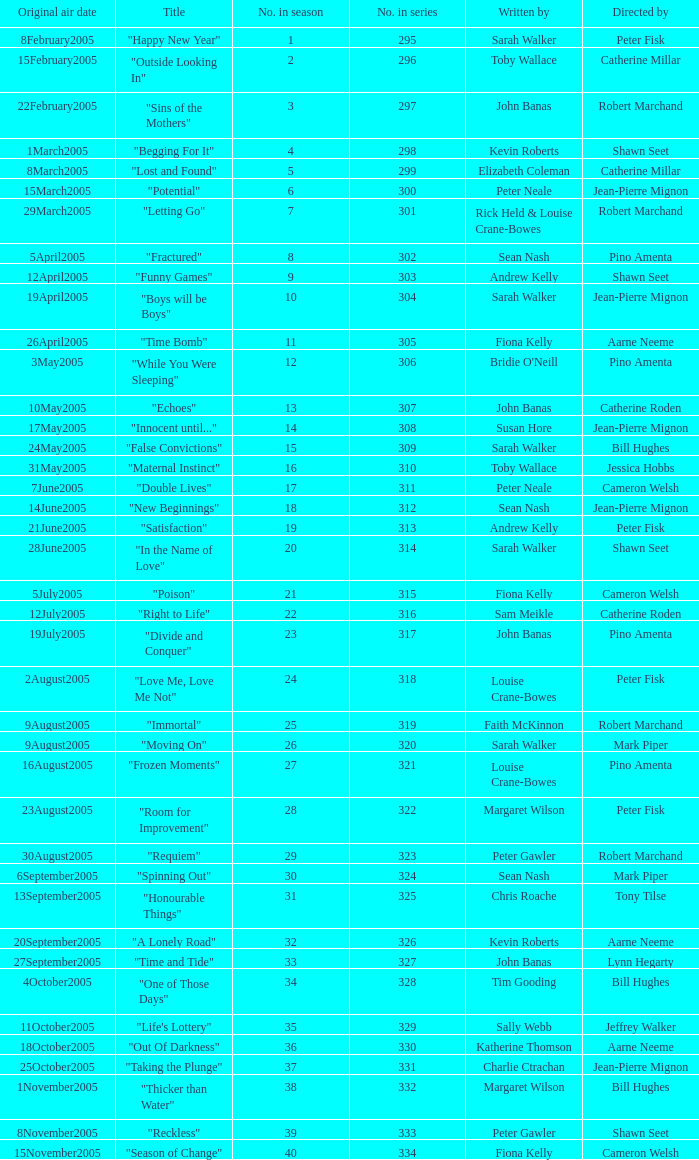Name the total number in the series written by john banas and directed by pino amenta 1.0. 